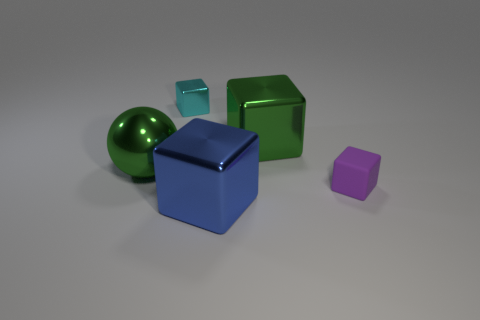There is a thing that is the same color as the ball; what shape is it?
Your response must be concise. Cube. Are the green thing that is left of the small cyan shiny object and the blue block made of the same material?
Ensure brevity in your answer.  Yes. There is a small cube that is on the right side of the tiny block to the left of the purple matte thing; what is its material?
Make the answer very short. Rubber. How many tiny gray rubber things are the same shape as the purple thing?
Keep it short and to the point. 0. What is the size of the shiny object that is in front of the tiny thing in front of the large shiny object on the right side of the big blue shiny thing?
Ensure brevity in your answer.  Large. What number of purple things are either metal spheres or small metallic objects?
Ensure brevity in your answer.  0. Do the tiny object behind the tiny purple rubber object and the small purple object have the same shape?
Your answer should be compact. Yes. Is the number of cyan shiny blocks that are in front of the big blue block greater than the number of gray cubes?
Provide a succinct answer. No. What number of green balls have the same size as the blue block?
Make the answer very short. 1. There is a shiny thing that is the same color as the large ball; what is its size?
Ensure brevity in your answer.  Large. 